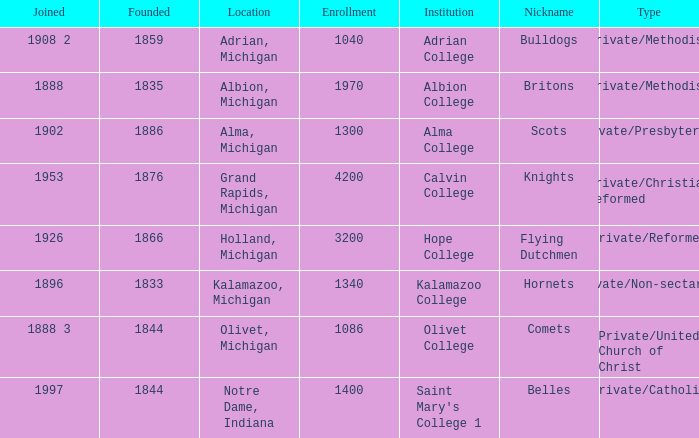Which categories fit under the institution calvin college? Private/Christian Reformed. 